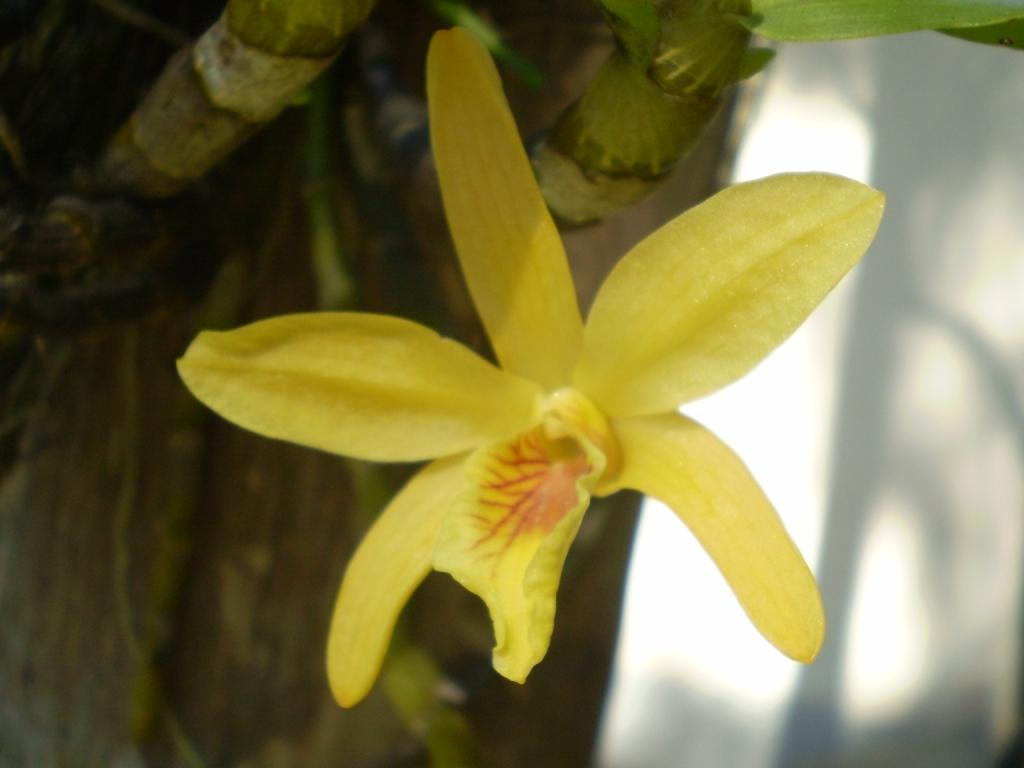What is the main subject in the middle of the image? There is a yellow flower in the middle of the image. What can be seen on the left side of the image? There is a tree on the left side of the image. What is the color and location of the area on the right side of the image? There is a white area on the right side of the image. Where is the grandmother sitting with the baby in the crib in the image? There is no grandmother, baby, or crib present in the image. 